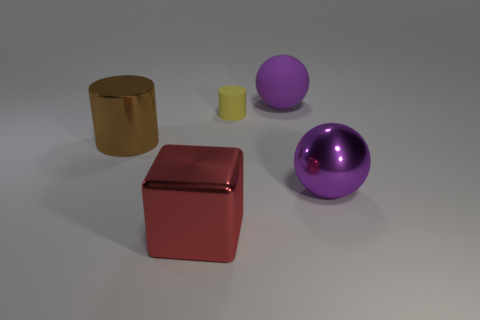Add 5 large brown metallic cylinders. How many objects exist? 10 Subtract all balls. How many objects are left? 3 Add 4 large purple rubber objects. How many large purple rubber objects exist? 5 Subtract 0 green balls. How many objects are left? 5 Subtract all large purple spheres. Subtract all large purple things. How many objects are left? 1 Add 3 tiny yellow cylinders. How many tiny yellow cylinders are left? 4 